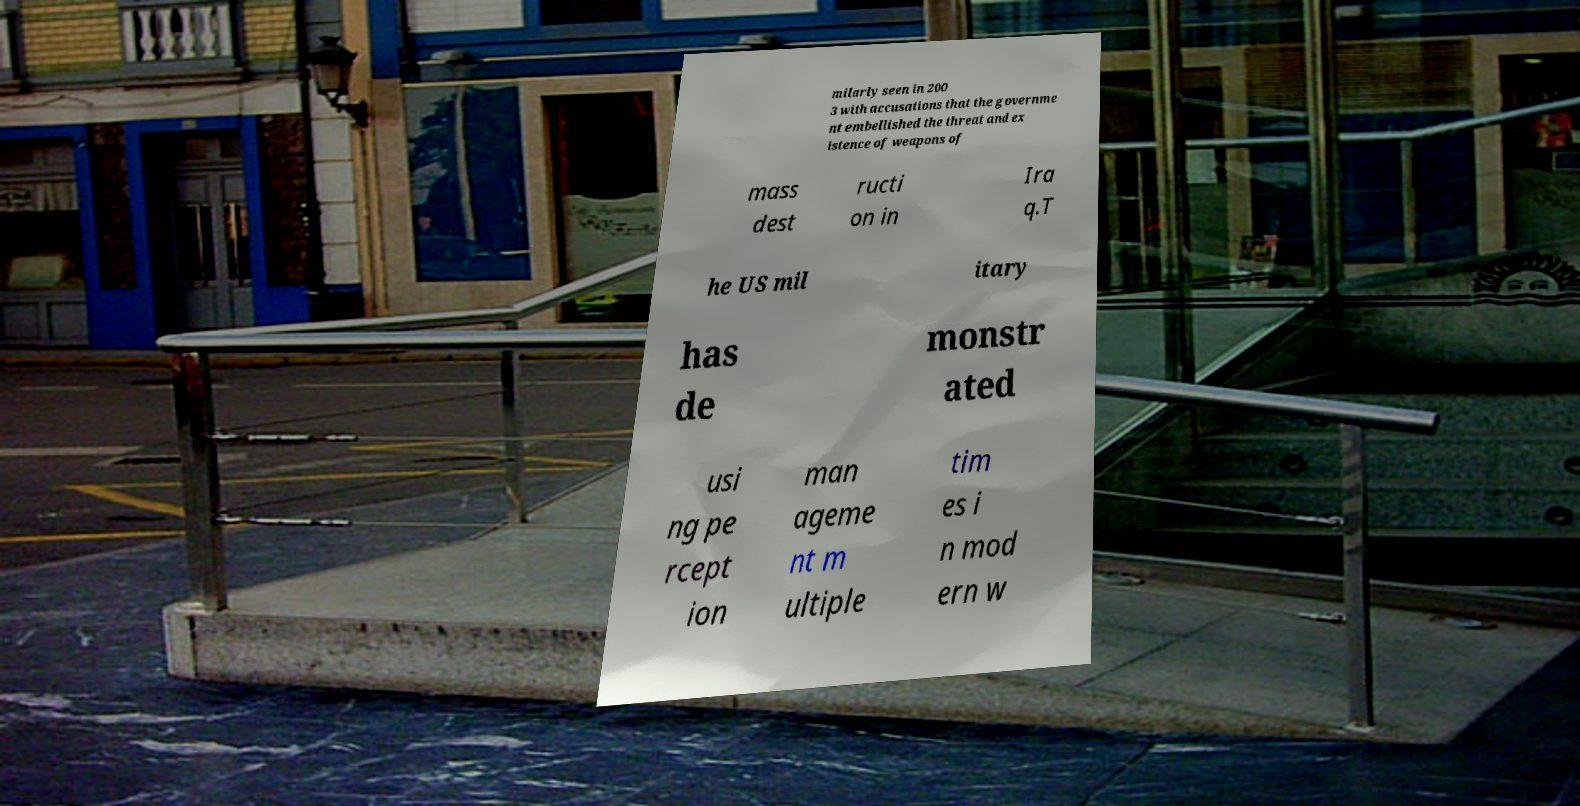I need the written content from this picture converted into text. Can you do that? milarly seen in 200 3 with accusations that the governme nt embellished the threat and ex istence of weapons of mass dest ructi on in Ira q.T he US mil itary has de monstr ated usi ng pe rcept ion man ageme nt m ultiple tim es i n mod ern w 